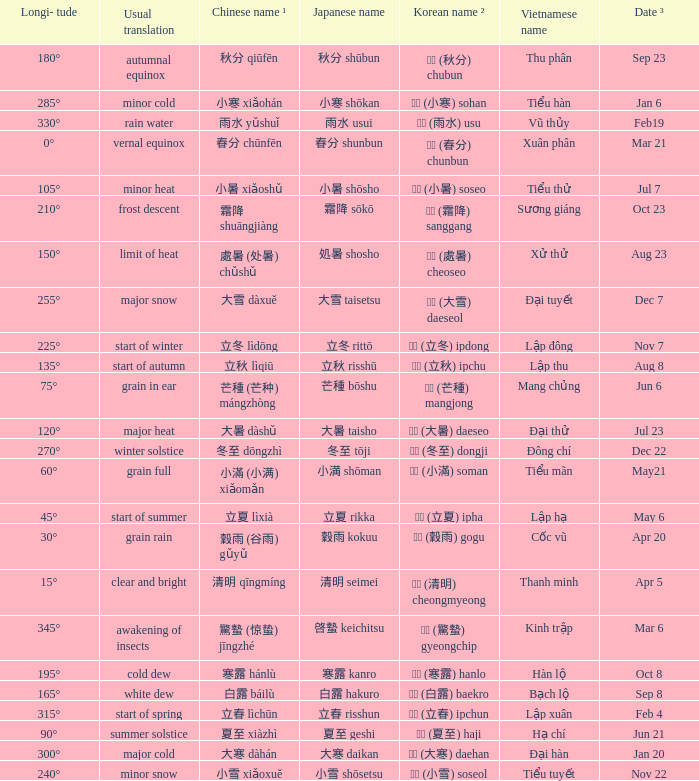WHICH Usual translation is on jun 21? Summer solstice. 